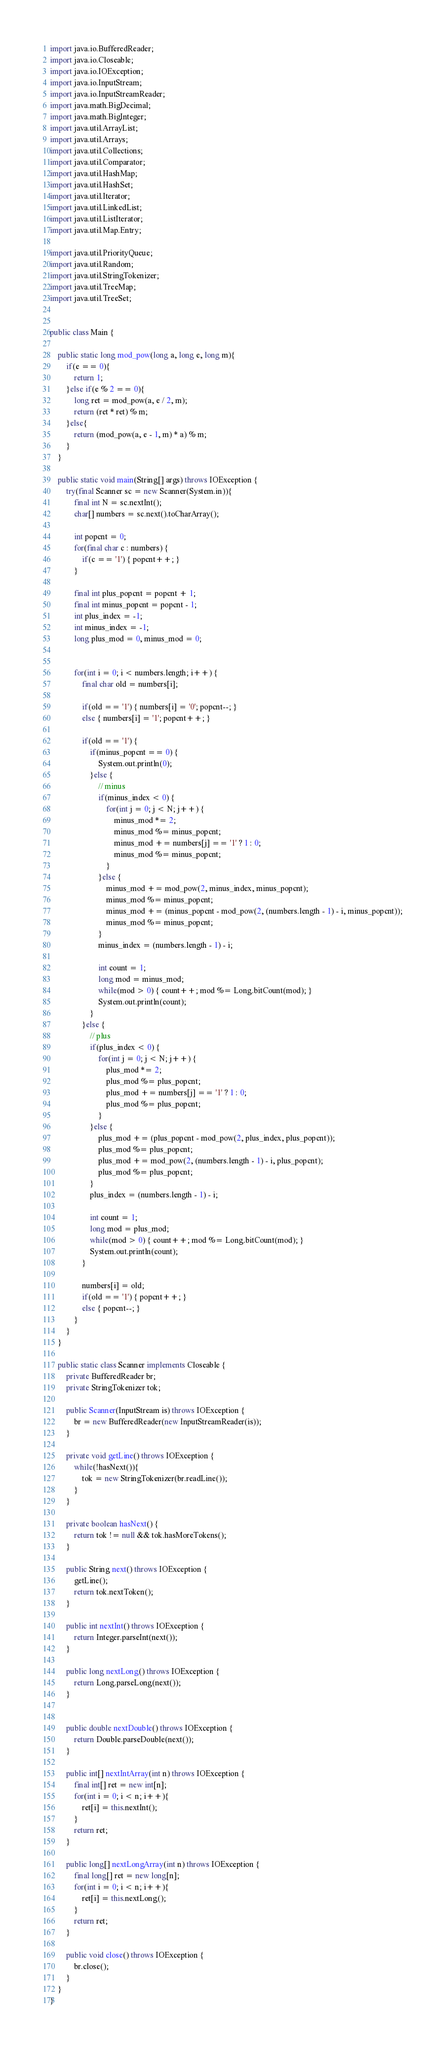<code> <loc_0><loc_0><loc_500><loc_500><_Java_>import java.io.BufferedReader;
import java.io.Closeable;
import java.io.IOException;
import java.io.InputStream;
import java.io.InputStreamReader;
import java.math.BigDecimal;
import java.math.BigInteger;
import java.util.ArrayList;
import java.util.Arrays;
import java.util.Collections;
import java.util.Comparator;
import java.util.HashMap;
import java.util.HashSet;
import java.util.Iterator;
import java.util.LinkedList;
import java.util.ListIterator;
import java.util.Map.Entry;

import java.util.PriorityQueue;
import java.util.Random;
import java.util.StringTokenizer;
import java.util.TreeMap;
import java.util.TreeSet;


public class Main {
	
	public static long mod_pow(long a, long e, long m){
		if(e == 0){
			return 1;
		}else if(e % 2 == 0){
			long ret = mod_pow(a, e / 2, m);
			return (ret * ret) % m;
		}else{
			return (mod_pow(a, e - 1, m) * a) % m;
		}
	}
	
	public static void main(String[] args) throws IOException {	
		try(final Scanner sc = new Scanner(System.in)){
			final int N = sc.nextInt();
			char[] numbers = sc.next().toCharArray();
			
			int popcnt = 0;
			for(final char c : numbers) {
				if(c == '1') { popcnt++; }
			}

			final int plus_popcnt = popcnt + 1;
			final int minus_popcnt = popcnt - 1;
			int plus_index = -1;
			int minus_index = -1;
			long plus_mod = 0, minus_mod = 0;
			
			
			for(int i = 0; i < numbers.length; i++) {
				final char old = numbers[i]; 
				
				if(old == '1') { numbers[i] = '0'; popcnt--; }
				else { numbers[i] = '1'; popcnt++; }
				
				if(old == '1') {
					if(minus_popcnt == 0) {
						System.out.println(0);
					}else {
						// minus
						if(minus_index < 0) {
							for(int j = 0; j < N; j++) {
								minus_mod *= 2;
								minus_mod %= minus_popcnt;
								minus_mod += numbers[j] == '1' ? 1 : 0;
								minus_mod %= minus_popcnt;
							}
						}else {
							minus_mod += mod_pow(2, minus_index, minus_popcnt);
							minus_mod %= minus_popcnt;
							minus_mod += (minus_popcnt - mod_pow(2, (numbers.length - 1) - i, minus_popcnt));
							minus_mod %= minus_popcnt;
						}
						minus_index = (numbers.length - 1) - i;
						
						int count = 1;
						long mod = minus_mod;
						while(mod > 0) { count++; mod %= Long.bitCount(mod); }
						System.out.println(count);
					}
				}else {
					// plus
					if(plus_index < 0) {
						for(int j = 0; j < N; j++) {
							plus_mod *= 2;
							plus_mod %= plus_popcnt;
							plus_mod += numbers[j] == '1' ? 1 : 0;
							plus_mod %= plus_popcnt;
						}
					}else {
						plus_mod += (plus_popcnt - mod_pow(2, plus_index, plus_popcnt));
						plus_mod %= plus_popcnt;
						plus_mod += mod_pow(2, (numbers.length - 1) - i, plus_popcnt);
						plus_mod %= plus_popcnt;
					}
					plus_index = (numbers.length - 1) - i;
					
					int count = 1;
					long mod = plus_mod;
					while(mod > 0) { count++; mod %= Long.bitCount(mod); }
					System.out.println(count);
				}
				
				numbers[i] = old;
				if(old == '1') { popcnt++; }
				else { popcnt--; }
			}
		}
	}

	public static class Scanner implements Closeable {
		private BufferedReader br;
		private StringTokenizer tok;

		public Scanner(InputStream is) throws IOException {
			br = new BufferedReader(new InputStreamReader(is));
		}

		private void getLine() throws IOException {
			while(!hasNext()){
				tok = new StringTokenizer(br.readLine());
			}
		}

		private boolean hasNext() {
			return tok != null && tok.hasMoreTokens();
		}

		public String next() throws IOException {
			getLine();
			return tok.nextToken();
		}

		public int nextInt() throws IOException {
			return Integer.parseInt(next());
		}

		public long nextLong() throws IOException {
			return Long.parseLong(next());
		}
		

		public double nextDouble() throws IOException {
			return Double.parseDouble(next());
		}

		public int[] nextIntArray(int n) throws IOException {
			final int[] ret = new int[n];
			for(int i = 0; i < n; i++){
				ret[i] = this.nextInt();
			}
			return ret;
		}

		public long[] nextLongArray(int n) throws IOException {
			final long[] ret = new long[n];
			for(int i = 0; i < n; i++){
				ret[i] = this.nextLong();
			}
			return ret;
		}

		public void close() throws IOException {
			br.close();
		}
	}
}
</code> 